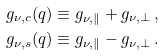Convert formula to latex. <formula><loc_0><loc_0><loc_500><loc_500>g _ { \nu , c } ( q ) \equiv g _ { \nu , \| } + g _ { \nu , \perp } \, , \\ g _ { \nu , s } ( q ) \equiv g _ { \nu , \| } - g _ { \nu , \perp } \, .</formula> 